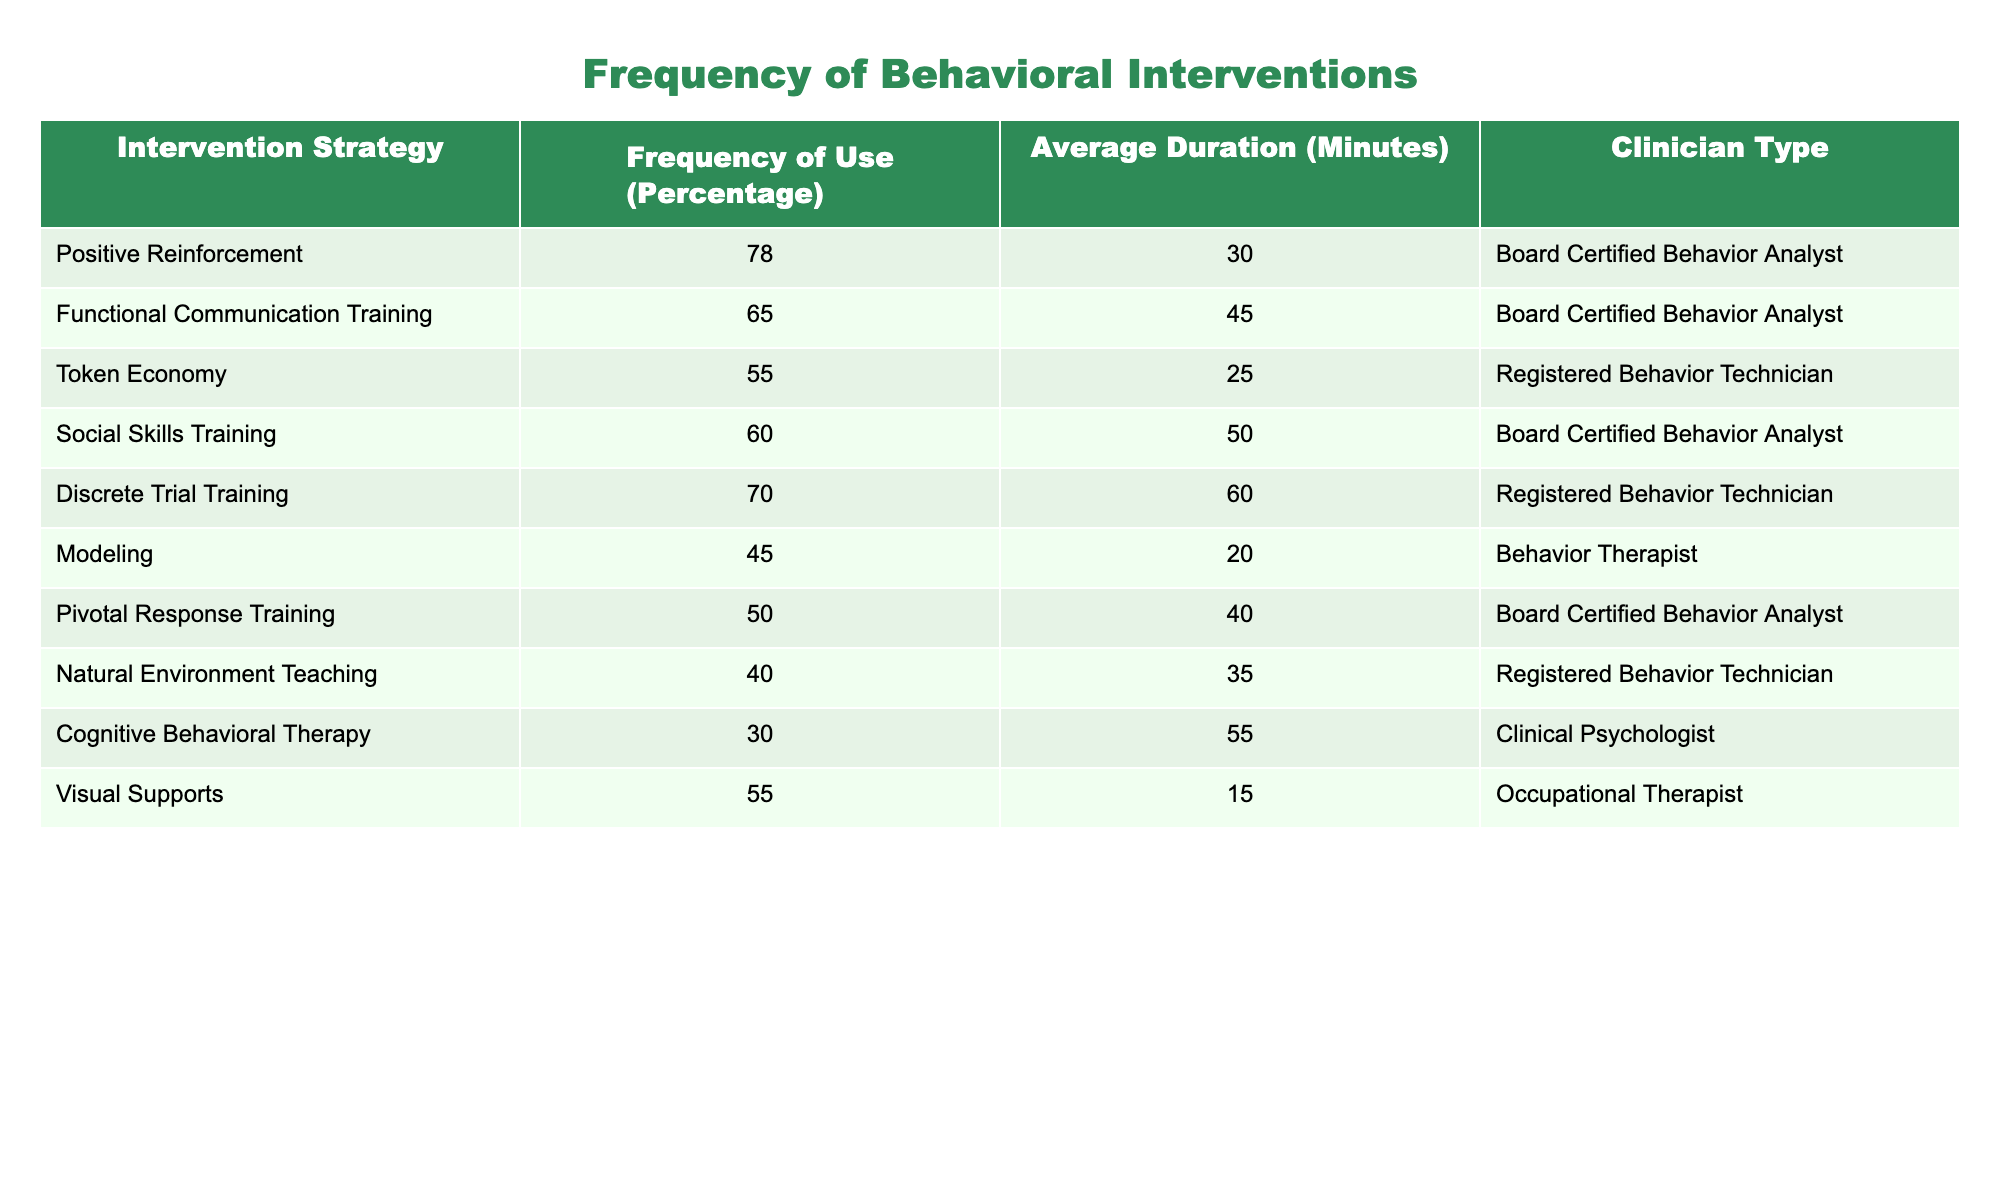What is the most frequently used behavioral intervention strategy? The table lists various intervention strategies along with their frequencies. The highest frequency percentage is 78 for Positive Reinforcement, which indicates that it is the most frequently used strategy.
Answer: 78 What is the average duration of Functional Communication Training? The table shows that the duration for Functional Communication Training is 45 minutes. Therefore, the average duration is simply the value given in the table.
Answer: 45 Which clinician type used Token Economy the most? The Token Economy is utilized by Registered Behavior Technicians, as indicated in the table.
Answer: Registered Behavior Technician What percentage of clinicians used Modeling compared to the percentage that used Pivotal Response Training? The percentage of clinicians who used Modeling is 45 and for Pivotal Response Training, it is 50. The difference is 50 - 45 = 5, which means a slightly higher percentage used Pivotal Response Training.
Answer: 5 Did any clinician type utilize Cognitive Behavioral Therapy? The table indicates that Cognitive Behavioral Therapy was used by Clinical Psychologists, meaning this statement is true.
Answer: Yes What is the average frequency of all strategies used by Board Certified Behavior Analysts? The table shows the frequencies for Board Certified Behavior Analysts as 78, 65, 60, 70, and 50. The average is calculated as (78 + 65 + 60 + 70 + 50) / 5 = 63. The sum is 323, so the average frequency is 323 / 5 = 64.6, which we can round to 65.
Answer: 65 Which intervention strategy had the lowest frequency of use, and what was that frequency? Reviewing the frequencies in the table, Cognitive Behavioral Therapy has the lowest frequency of use at 30 percent.
Answer: 30 How many minutes on average do Registered Behavior Technicians spend using the strategies listed? The table lists the durations for Registered Behavior Technicians as 25 and 35 minutes for Token Economy and Natural Environment Training. The average is calculated as (25 + 35) / 2 = 30.
Answer: 30 What percentage of clinicians utilized social skills training in the past year? According to the table, the percentage of clinicians who used Social Skills Training is 60. So, the answer is directly taken from this entry.
Answer: 60 